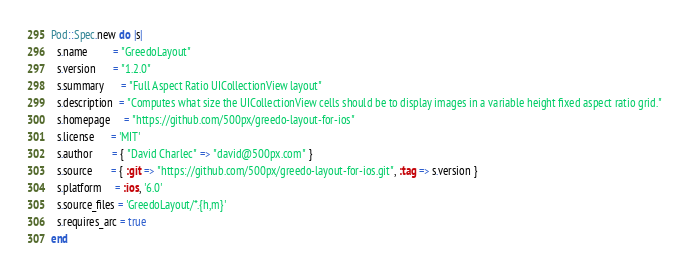<code> <loc_0><loc_0><loc_500><loc_500><_Ruby_>Pod::Spec.new do |s|
  s.name         = "GreedoLayout"
  s.version      = "1.2.0"
  s.summary      = "Full Aspect Ratio UICollectionView layout"
  s.description  = "Computes what size the UICollectionView cells should be to display images in a variable height fixed aspect ratio grid."
  s.homepage     = "https://github.com/500px/greedo-layout-for-ios"
  s.license      = 'MIT'
  s.author       = { "David Charlec" => "david@500px.com" }
  s.source       = { :git => "https://github.com/500px/greedo-layout-for-ios.git", :tag => s.version }
  s.platform     = :ios, '6.0'
  s.source_files = 'GreedoLayout/*.{h,m}'
  s.requires_arc = true
end
</code> 